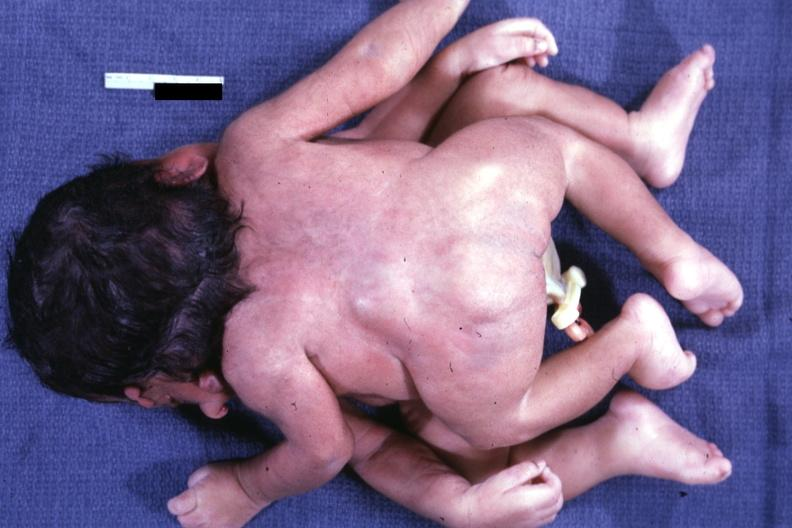s cephalothoracopagus janiceps present?
Answer the question using a single word or phrase. Yes 